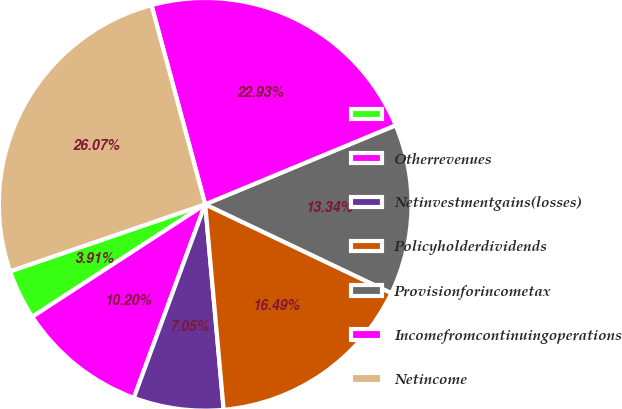<chart> <loc_0><loc_0><loc_500><loc_500><pie_chart><ecel><fcel>Otherrevenues<fcel>Netinvestmentgains(losses)<fcel>Policyholderdividends<fcel>Provisionforincometax<fcel>Incomefromcontinuingoperations<fcel>Netincome<nl><fcel>3.91%<fcel>10.2%<fcel>7.05%<fcel>16.49%<fcel>13.34%<fcel>22.93%<fcel>26.07%<nl></chart> 